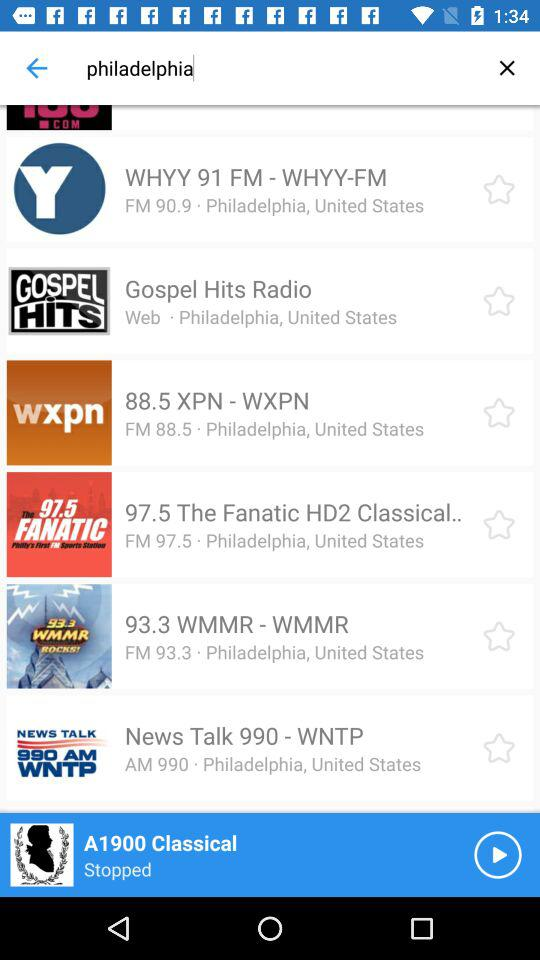Which music is currently being played? The music currently being played is "A1900 Classical". 